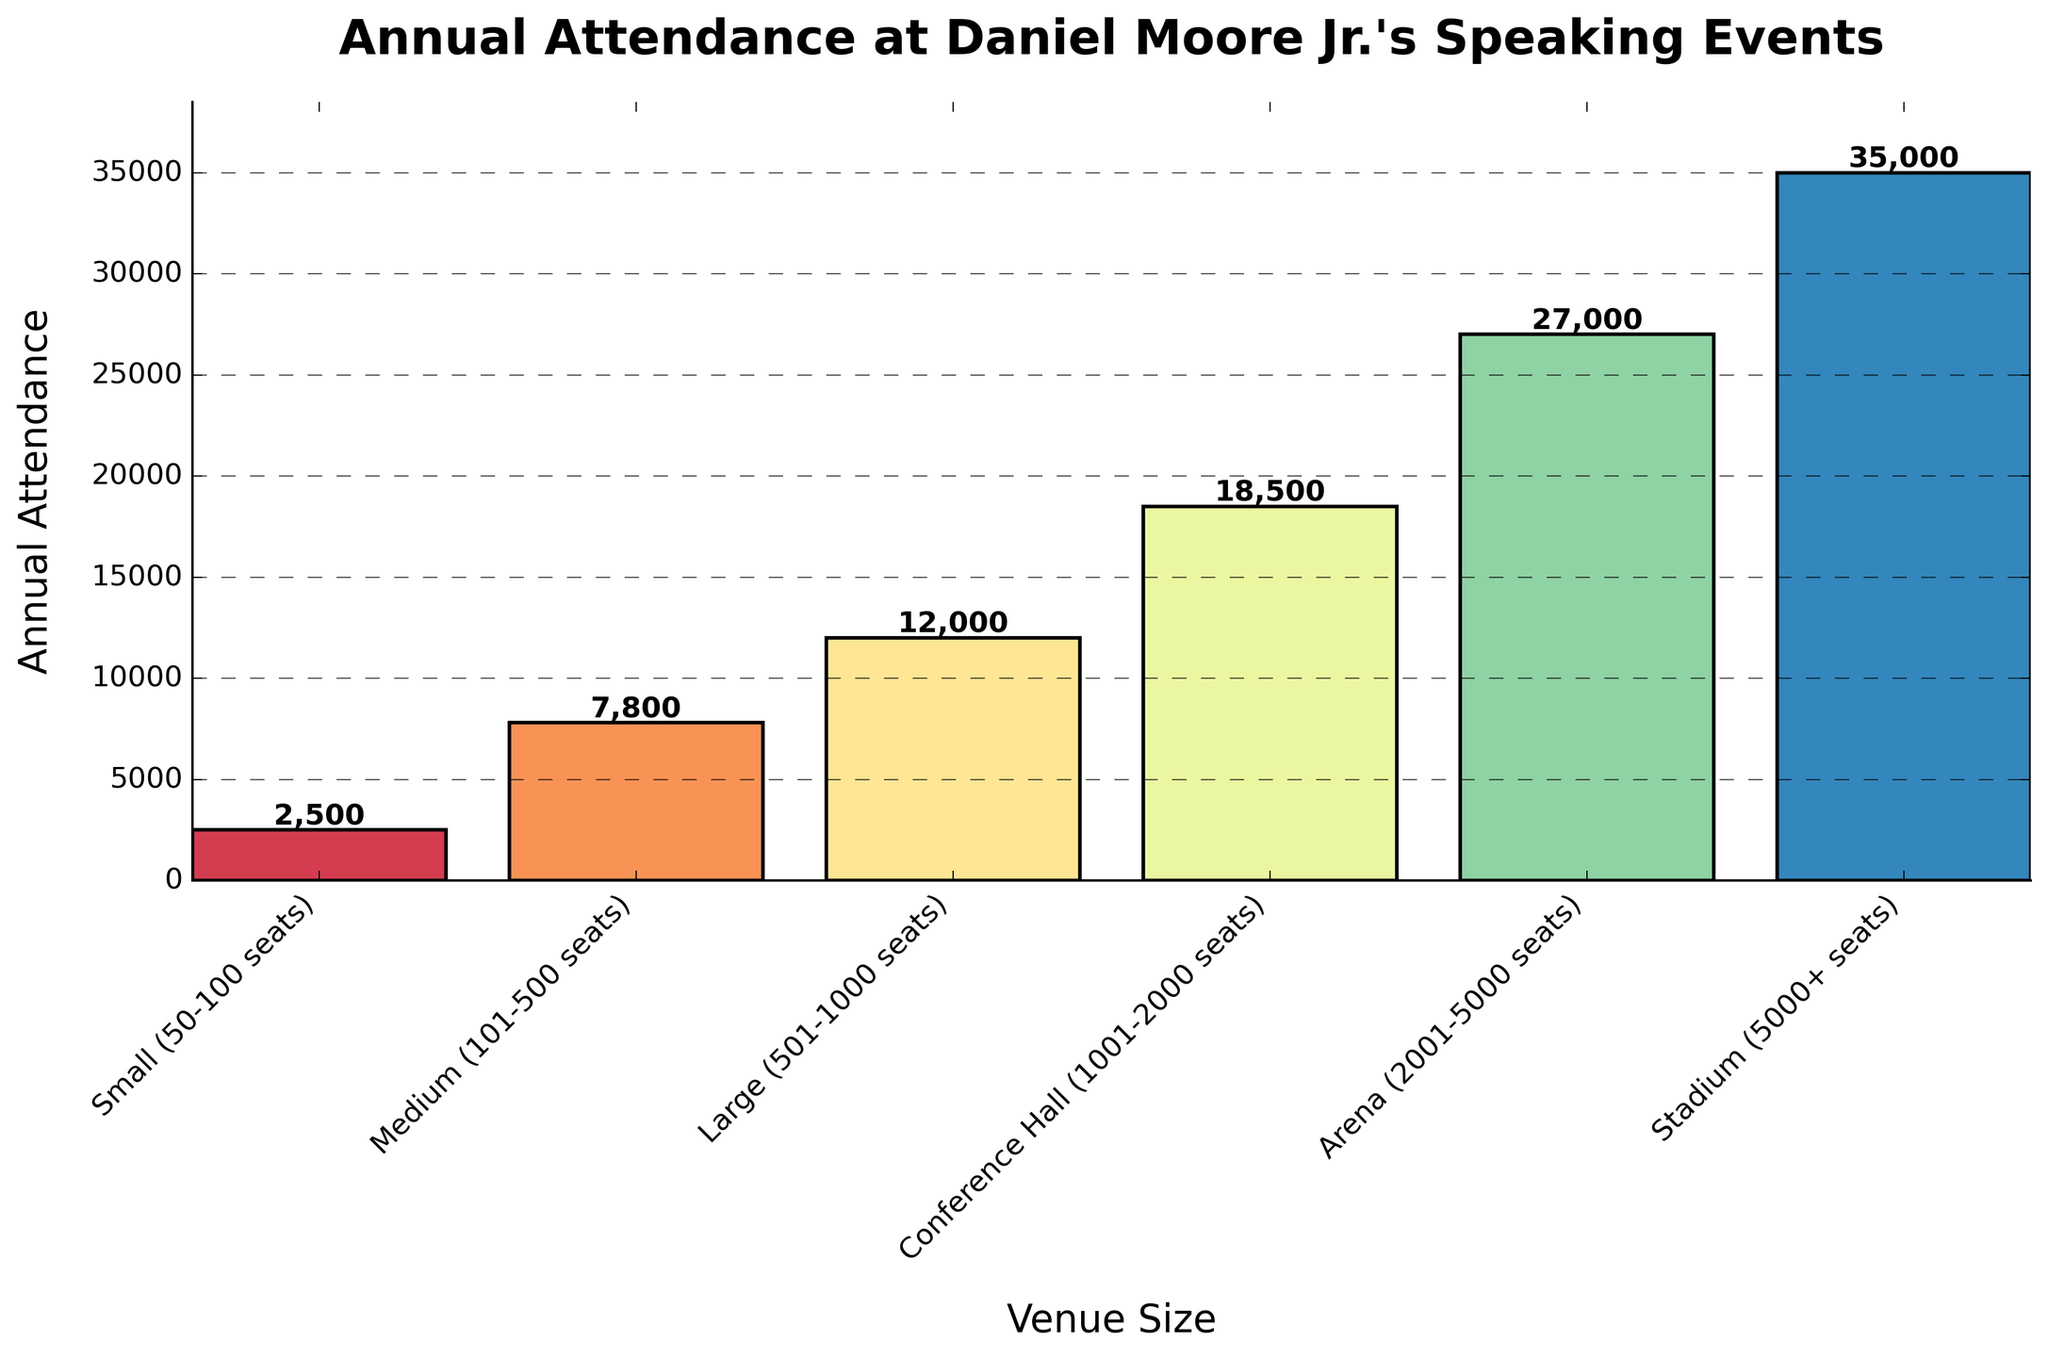What is the total annual attendance for all venue sizes combined? To find the total annual attendance, sum the attendance numbers from all venue sizes: 2500 (Small) + 7800 (Medium) + 12000 (Large) + 18500 (Conference Hall) + 27000 (Arena) + 35000 (Stadium).
Answer: 102800 How does the annual attendance at Stadium compare to Conference Hall? Compare the attendance numbers for Stadium and Conference Hall. Stadium has 35000 attendees, while Conference Hall has 18500 attendees, so Stadium has more.
Answer: Stadium has more Which venue size has the least annual attendance? Look for the lowest value among the attendance numbers. The smallest value is 2500 for Small venues.
Answer: Small By how much does the attendance at Arena exceed the attendance at Large venues? Subtract the attendance for Large venues (12000) from the attendance for Arena (27000): 27000 - 12000 = 15000.
Answer: 15000 What is the average annual attendance across all venue sizes? Sum all the attendance values, then divide by the number of venue sizes: (2500 + 7800 + 12000 + 18500 + 27000 + 35000) / 6.
Answer: 17133.33 Which two venue sizes have the closest annual attendance figures? The closest attendance figures are for Small (2500) and Medium (7800), with a difference of 5300, which is smaller than the difference between any other pairs.
Answer: Small and Medium How does the attendance for Large and Arena venues combined compare to the total attendance? First, sum the attendance for Large (12000) and Arena (27000): 12000 + 27000 = 39000. Then, compare it to the total attendance of 102800 and see if it's less: 39000 < 102800.
Answer: Less Which venue size accounts for the highest percentage of the total annual attendance? Find the percentage of each venue size and compare. For Stadium: (35000 / 102800) * 100 = 34.06%, which is the highest.
Answer: Stadium Are smaller venue sizes (Small, Medium) collectively accounting for more or fewer attendees than larger venue sizes (Large, Conference Hall, Arena, Stadium)? Sum attendance for smaller venues: 2500 (Small) + 7800 (Medium) = 10300. Sum for larger venues: 12000 (Large) + 18500 (Conference Hall) + 27000 (Arena) + 35000 (Stadium) = 92500. Compare sums: 10300 < 92500.
Answer: Fewer What is the difference in annual attendance between the venue size with the highest attendance and the venue size with the lowest attendance? Subtract the smallest attendance (2500) from the highest attendance (35000): 35000 - 2500 = 32500.
Answer: 32500 